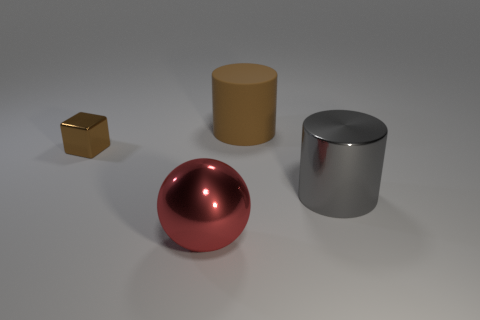Add 1 big blue things. How many objects exist? 5 Subtract all spheres. How many objects are left? 3 Add 2 gray metallic cylinders. How many gray metallic cylinders exist? 3 Subtract 0 gray blocks. How many objects are left? 4 Subtract all brown cubes. Subtract all brown rubber cylinders. How many objects are left? 2 Add 3 spheres. How many spheres are left? 4 